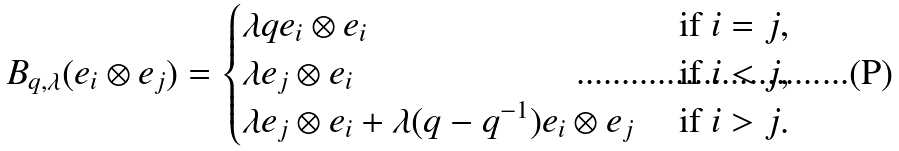Convert formula to latex. <formula><loc_0><loc_0><loc_500><loc_500>B _ { q , \lambda } ( e _ { i } \otimes e _ { j } ) = \begin{cases} \lambda q e _ { i } \otimes e _ { i } & \text { if $i = j$} , \\ \lambda e _ { j } \otimes e _ { i } & \text { if $i < j$} , \\ \lambda e _ { j } \otimes e _ { i } + \lambda ( q - q ^ { - 1 } ) e _ { i } \otimes e _ { j } & \text { if $i > j$} . \end{cases}</formula> 